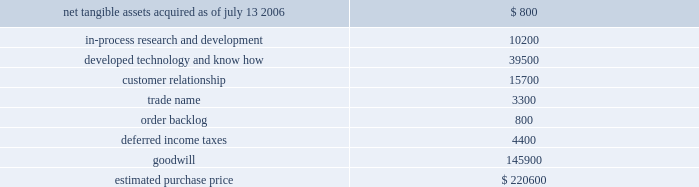Hologic , inc .
Notes to consolidated financial statements ( continued ) ( in thousands , except per share data ) determination of the measurement date for the market price of acquirer securities issued in a purchase business combination .
The components and allocation of the purchase price , consists of the following approximate amounts: .
The company has begun to assess and formulate a plan to restructure certain of r2 2019s historical activities .
As of the acquisition date the company recorded a liability of approximately $ 798 in accordance with eitf issue no .
95-3 , recognition of liabilities in connection with a purchase business combination , related to the termination of certain employees and loss related to the abandonment of certain lease space under this plan of which approximately $ 46 has been paid as of september 30 , 2006 .
The company believes this plan will be finalized within one year from the acquisition date and will record any additional liabilities at such time resulting in an increase to goodwill .
The final purchase price allocations will be completed within one year of the acquisition and any adjustments are not expected to have a material impact on the company 2019s financial position or results of operation .
As part of the purchase price allocation , all intangible assets that were a part of the acquisition were identified and valued .
It was determined that only customer relationships , trademarks and developed technology had separately identifiable values .
Customer relationships represent r2 2019s strong active customer base , dominant market position and strong partnership with several large companies .
Trademarks represent the r2 product names that the company intends to continue to use .
Developed technology represents currently marketable purchased products that the company continues to resell as well as utilize to enhance and incorporate into the company 2019s existing products .
The estimated $ 10200 of purchase price allocated to in-process research and development projects primarily related to r2s digital cad products .
The projects are expected to add direct digital algorithm capabilities as well as a new platform technology to analyze images and breast density measurement .
The project is approximately 20% ( 20 % ) complete and the company expects to spend approximately $ 3100 over the year to complete .
The deferred income tax asset relates to the tax effect of acquired net operating loss carry forwards that the company believes are realizable partially offset by acquired identifiable intangible assets , and fair value adjustments to acquired inventory as such amounts are not deductible for tax purposes .
Acquisition of suros surgical systems , inc .
On july 27 , 2006 , the company completed the acquisition of suros surgical systems , inc. , pursuant to an agreement and plan of merger dated april 17 , 2006 .
The results of operations for suros have been included in the company 2019s consolidated financial statements from the date of acquisition as part of its mammography business segment .
Suros surgical , located in indianapolis , indiana , develops , manufactures and sells minimally invasive interventional breast biopsy technology and products for biopsy , tissue removal and biopsy site marking. .
What percentage of the estimated purchase price is developed technology and know how? 
Computations: (39500 / 220600)
Answer: 0.17906. 